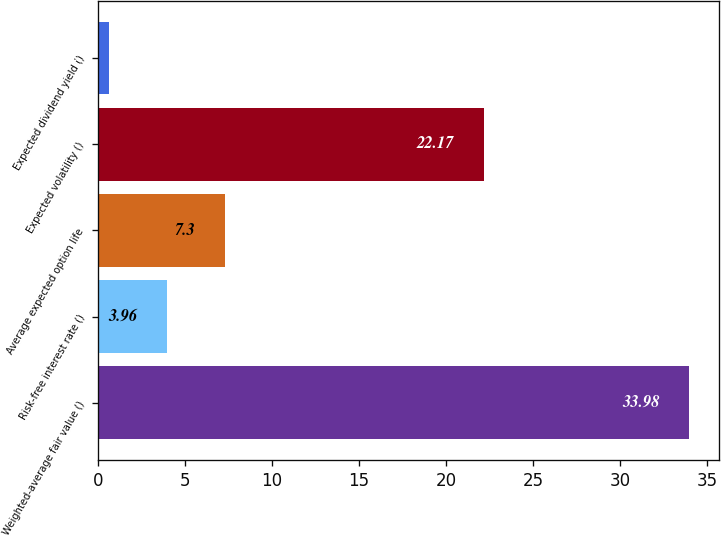Convert chart to OTSL. <chart><loc_0><loc_0><loc_500><loc_500><bar_chart><fcel>Weighted-average fair value ()<fcel>Risk-free interest rate ()<fcel>Average expected option life<fcel>Expected volatility ()<fcel>Expected dividend yield ()<nl><fcel>33.98<fcel>3.96<fcel>7.3<fcel>22.17<fcel>0.62<nl></chart> 